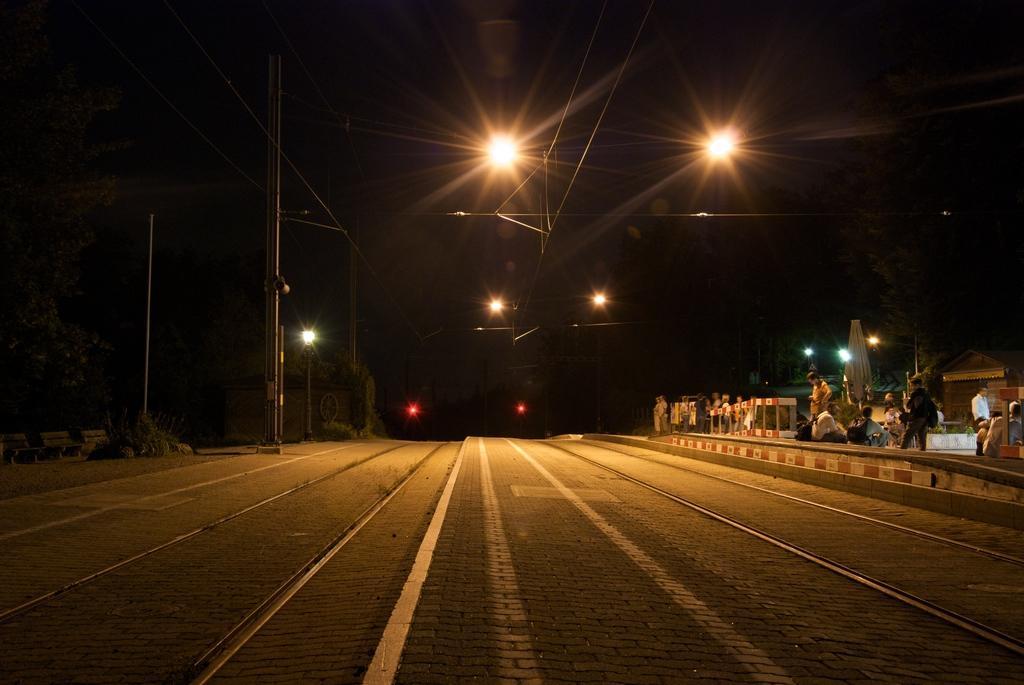How would you summarize this image in a sentence or two? In the picture we can see a road on the right hand side of the road we can see a platform with some people standing on it and on the opposite side, we can see some benches and poles on the path and on the top of the road we can see some electrical wires and lights and in the background we can see dark and on the road we can see some tracks. 